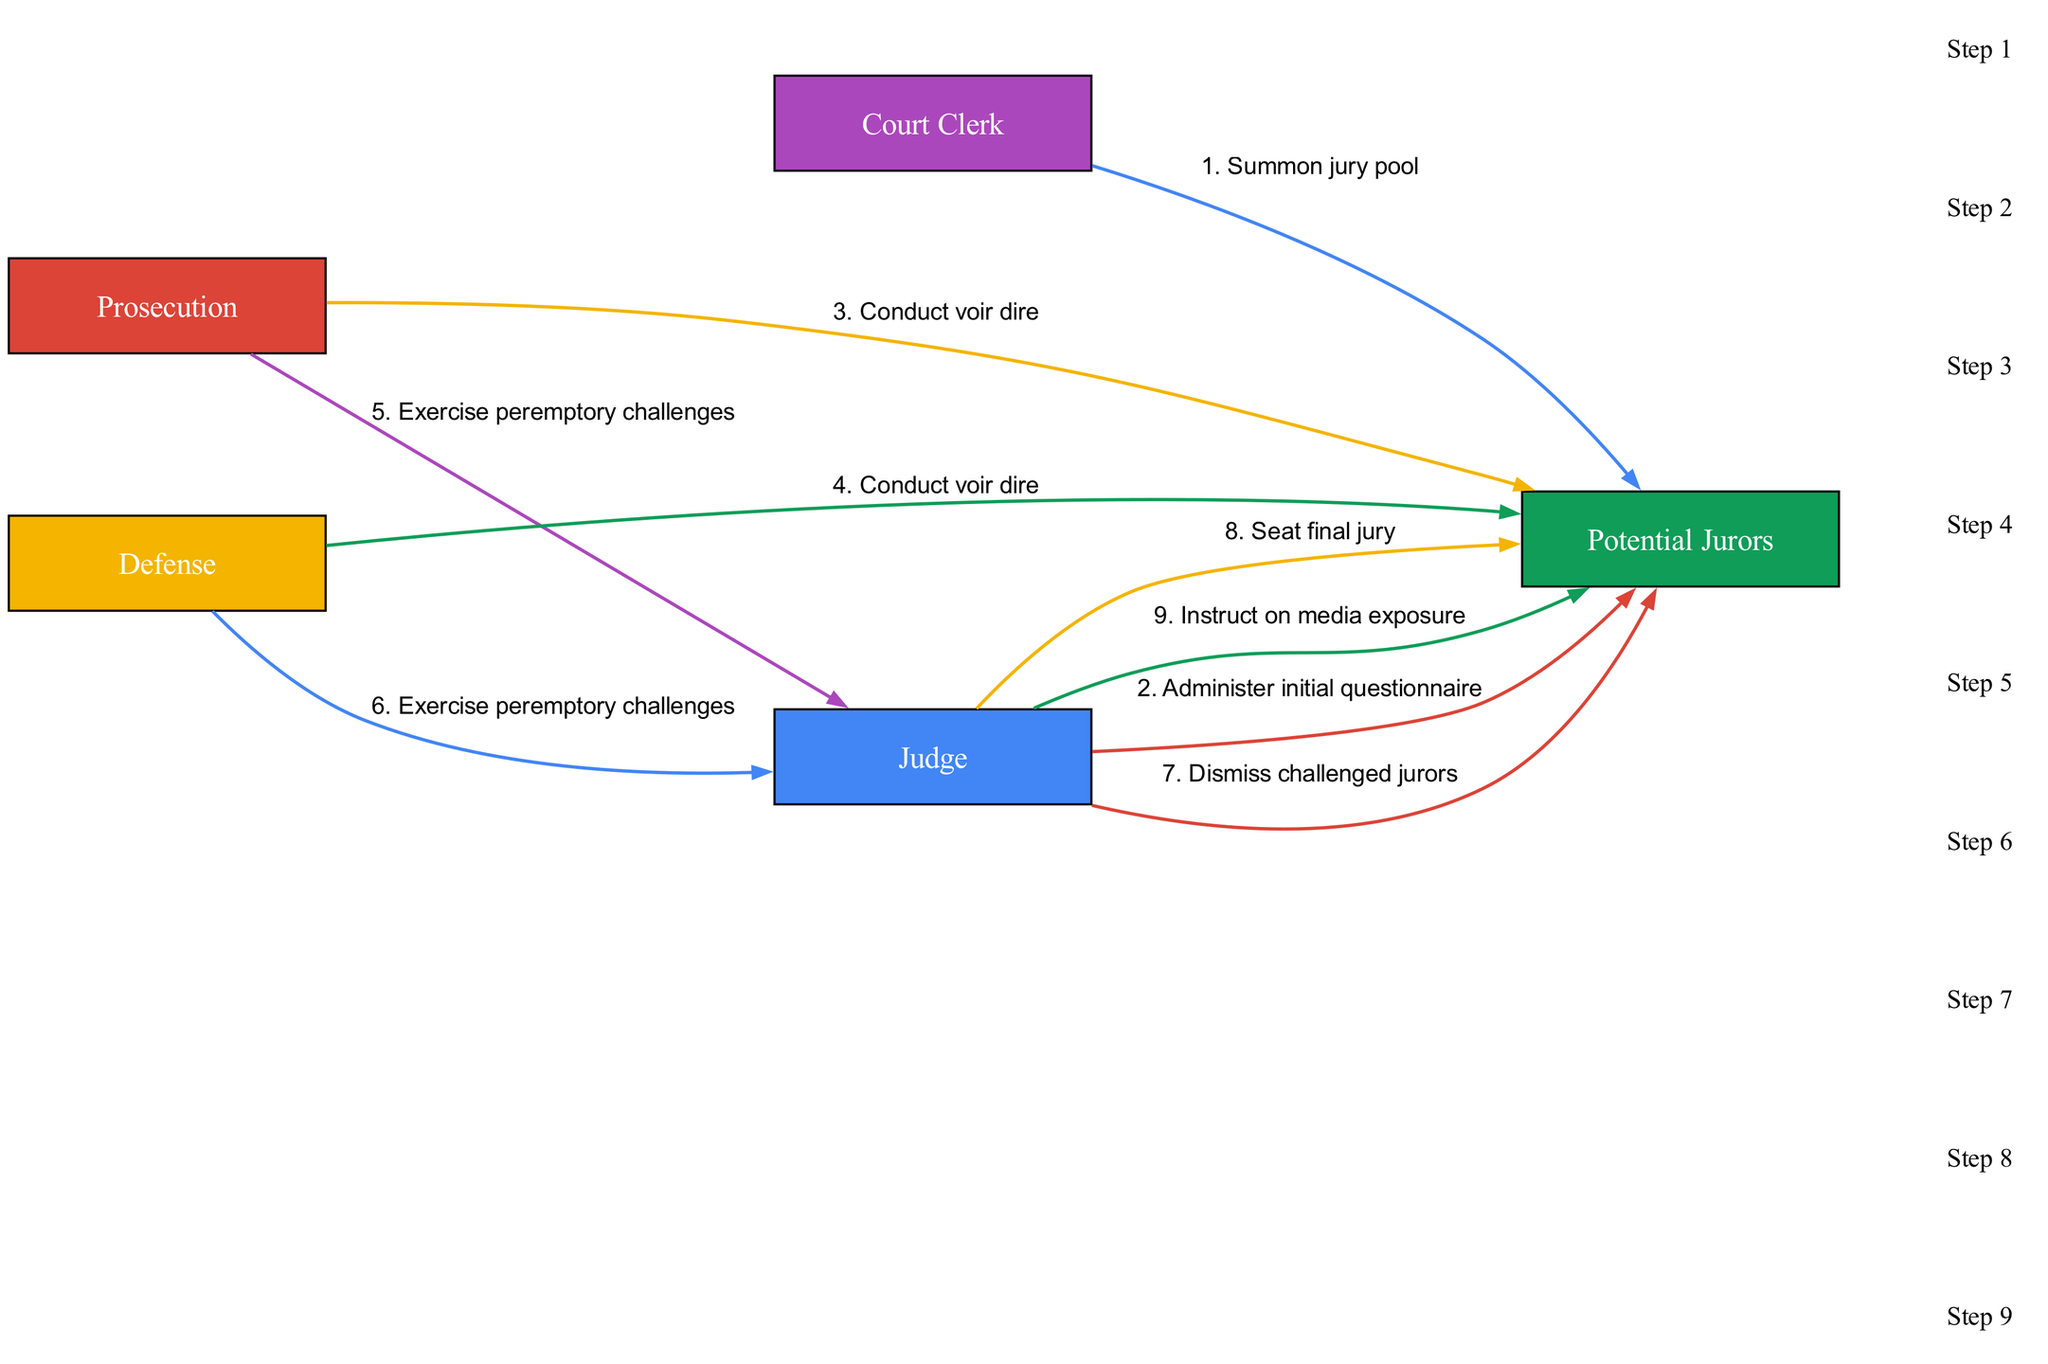What is the first action in the jury selection process? The first action in the diagram is depicted as "Summon jury pool" by the Court Clerk to the Potential Jurors. This is the initial step in the process.
Answer: Summon jury pool How many participants are involved in the jury selection process? The diagram lists five participants: Judge, Prosecution, Defense, Potential Jurors, and Court Clerk. Counting them gives a total of five participants.
Answer: Five Which action follows the initial questionnaire? After the initial questionnaire administered by the Judge, the next action is "Conduct voir dire" by the Prosecution. This sequence shows the process is continuing with further questioning of potential jurors.
Answer: Conduct voir dire What action is taken by both the Prosecution and Defense regarding jurors? Both the Prosecution and Defense exercise "peremptory challenges" directed towards the Judge. This indicates that they have a chance to dismiss specific jurors without needing to provide a reason.
Answer: Exercise peremptory challenges What happens to the challenged jurors? The Judge dismisses the challenged jurors after the Prosecution and Defense have exercised their peremptory challenges. This indicates a filtering process to form the final jury.
Answer: Dismiss challenged jurors What is the final action taken towards the Potential Jurors? The final action taken toward the Potential Jurors is "Seat final jury" performed by the Judge. This is the concluding step in the jury selection process, indicating the jurors who will participate in the trial.
Answer: Seat final jury Which participants are involved in the "Conduct voir dire" actions? The actions of "Conduct voir dire" involve both the Prosecution and the Defense talking to the Potential Jurors. This shows a collaborative effort from both sides to evaluate juror suitability.
Answer: Prosecution and Defense How many distinct actions are listed in the sequence? The sequence contains eight distinct actions related to various interactions between the participants and the Potential Jurors during the jury selection process. Each action represents a step in the overall procedure.
Answer: Eight 